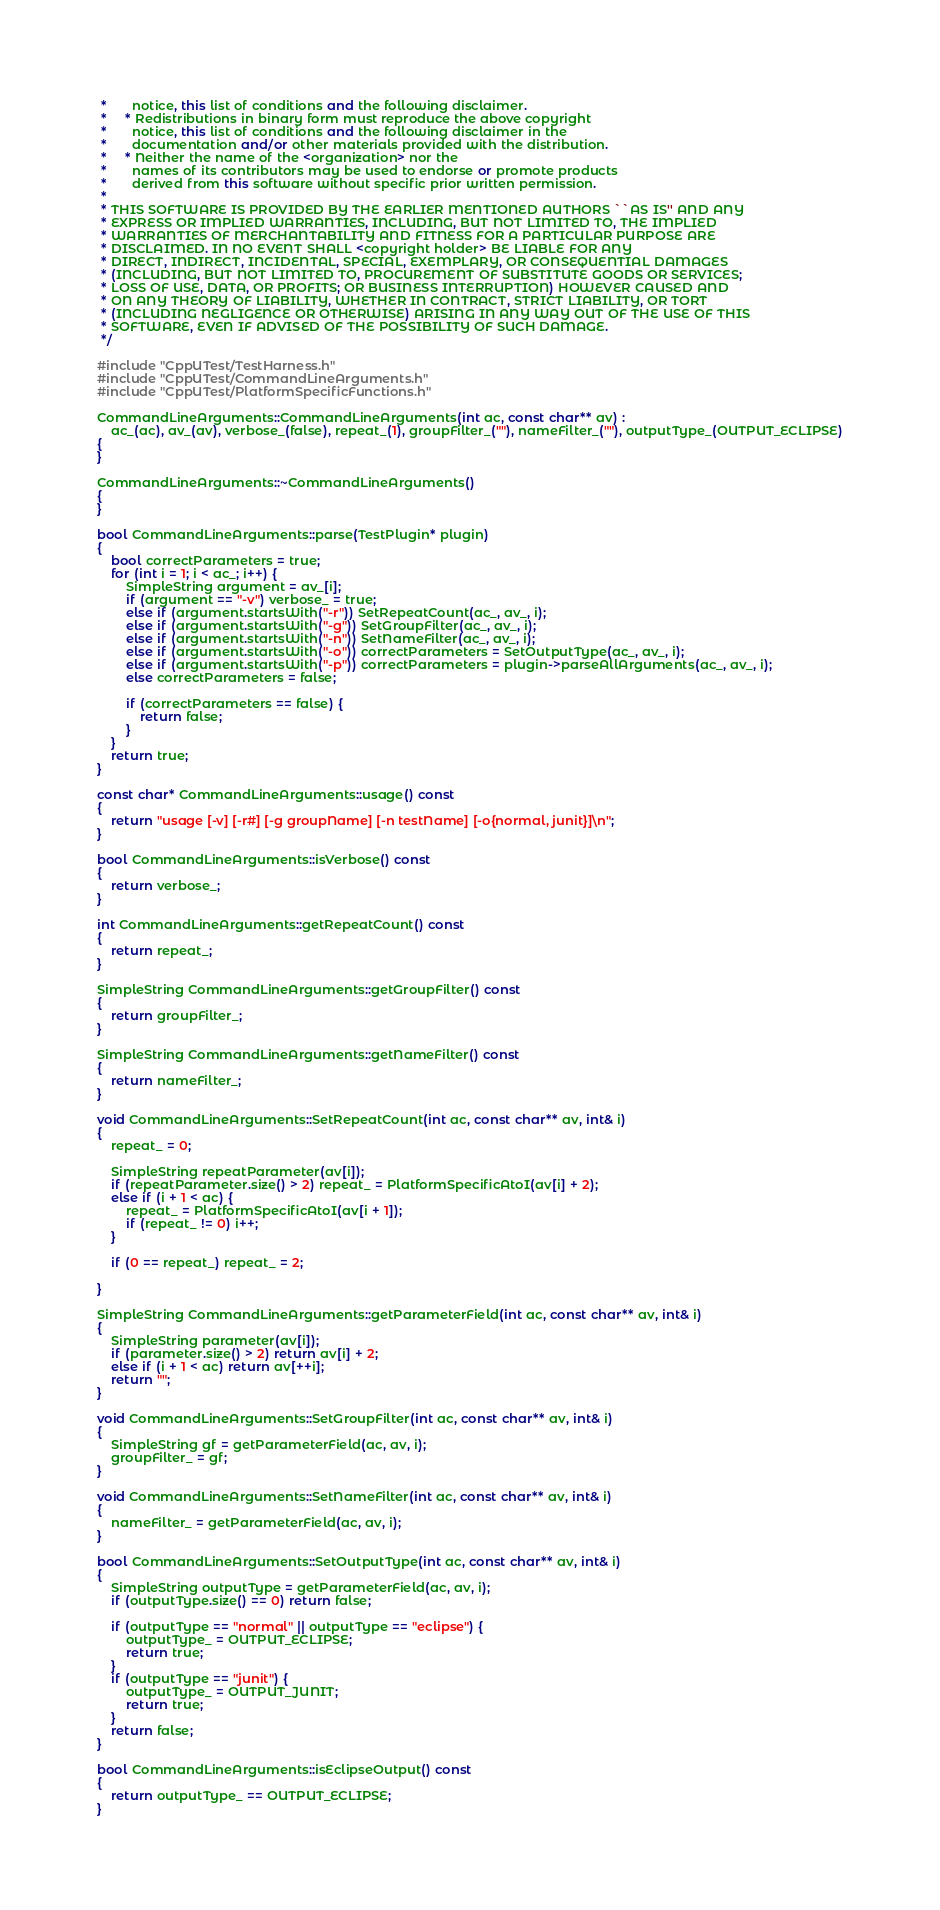<code> <loc_0><loc_0><loc_500><loc_500><_C++_> *       notice, this list of conditions and the following disclaimer.
 *     * Redistributions in binary form must reproduce the above copyright
 *       notice, this list of conditions and the following disclaimer in the
 *       documentation and/or other materials provided with the distribution.
 *     * Neither the name of the <organization> nor the
 *       names of its contributors may be used to endorse or promote products
 *       derived from this software without specific prior written permission.
 *
 * THIS SOFTWARE IS PROVIDED BY THE EARLIER MENTIONED AUTHORS ``AS IS'' AND ANY
 * EXPRESS OR IMPLIED WARRANTIES, INCLUDING, BUT NOT LIMITED TO, THE IMPLIED
 * WARRANTIES OF MERCHANTABILITY AND FITNESS FOR A PARTICULAR PURPOSE ARE
 * DISCLAIMED. IN NO EVENT SHALL <copyright holder> BE LIABLE FOR ANY
 * DIRECT, INDIRECT, INCIDENTAL, SPECIAL, EXEMPLARY, OR CONSEQUENTIAL DAMAGES
 * (INCLUDING, BUT NOT LIMITED TO, PROCUREMENT OF SUBSTITUTE GOODS OR SERVICES;
 * LOSS OF USE, DATA, OR PROFITS; OR BUSINESS INTERRUPTION) HOWEVER CAUSED AND
 * ON ANY THEORY OF LIABILITY, WHETHER IN CONTRACT, STRICT LIABILITY, OR TORT
 * (INCLUDING NEGLIGENCE OR OTHERWISE) ARISING IN ANY WAY OUT OF THE USE OF THIS
 * SOFTWARE, EVEN IF ADVISED OF THE POSSIBILITY OF SUCH DAMAGE.
 */

#include "CppUTest/TestHarness.h"
#include "CppUTest/CommandLineArguments.h"
#include "CppUTest/PlatformSpecificFunctions.h"

CommandLineArguments::CommandLineArguments(int ac, const char** av) :
	ac_(ac), av_(av), verbose_(false), repeat_(1), groupFilter_(""), nameFilter_(""), outputType_(OUTPUT_ECLIPSE)
{
}

CommandLineArguments::~CommandLineArguments()
{
}

bool CommandLineArguments::parse(TestPlugin* plugin)
{
	bool correctParameters = true;
	for (int i = 1; i < ac_; i++) {
		SimpleString argument = av_[i];
		if (argument == "-v") verbose_ = true;
		else if (argument.startsWith("-r")) SetRepeatCount(ac_, av_, i);
		else if (argument.startsWith("-g")) SetGroupFilter(ac_, av_, i);
		else if (argument.startsWith("-n")) SetNameFilter(ac_, av_, i);
		else if (argument.startsWith("-o")) correctParameters = SetOutputType(ac_, av_, i);
		else if (argument.startsWith("-p")) correctParameters = plugin->parseAllArguments(ac_, av_, i);
		else correctParameters = false;

		if (correctParameters == false) {
			return false;
		}
	}
	return true;
}

const char* CommandLineArguments::usage() const
{
	return "usage [-v] [-r#] [-g groupName] [-n testName] [-o{normal, junit}]\n";
}

bool CommandLineArguments::isVerbose() const
{
	return verbose_;
}

int CommandLineArguments::getRepeatCount() const
{
	return repeat_;
}

SimpleString CommandLineArguments::getGroupFilter() const
{
	return groupFilter_;
}

SimpleString CommandLineArguments::getNameFilter() const
{
	return nameFilter_;
}

void CommandLineArguments::SetRepeatCount(int ac, const char** av, int& i)
{
	repeat_ = 0;

	SimpleString repeatParameter(av[i]);
	if (repeatParameter.size() > 2) repeat_ = PlatformSpecificAtoI(av[i] + 2);
	else if (i + 1 < ac) {
		repeat_ = PlatformSpecificAtoI(av[i + 1]);
		if (repeat_ != 0) i++;
	}

	if (0 == repeat_) repeat_ = 2;

}

SimpleString CommandLineArguments::getParameterField(int ac, const char** av, int& i)
{
	SimpleString parameter(av[i]);
	if (parameter.size() > 2) return av[i] + 2;
	else if (i + 1 < ac) return av[++i];
	return "";
}

void CommandLineArguments::SetGroupFilter(int ac, const char** av, int& i)
{
	SimpleString gf = getParameterField(ac, av, i);
	groupFilter_ = gf;
}

void CommandLineArguments::SetNameFilter(int ac, const char** av, int& i)
{
	nameFilter_ = getParameterField(ac, av, i);
}

bool CommandLineArguments::SetOutputType(int ac, const char** av, int& i)
{
	SimpleString outputType = getParameterField(ac, av, i);
	if (outputType.size() == 0) return false;

	if (outputType == "normal" || outputType == "eclipse") {
		outputType_ = OUTPUT_ECLIPSE;
		return true;
	}
	if (outputType == "junit") {
		outputType_ = OUTPUT_JUNIT;
		return true;
	}
	return false;
}

bool CommandLineArguments::isEclipseOutput() const
{
	return outputType_ == OUTPUT_ECLIPSE;
}
</code> 